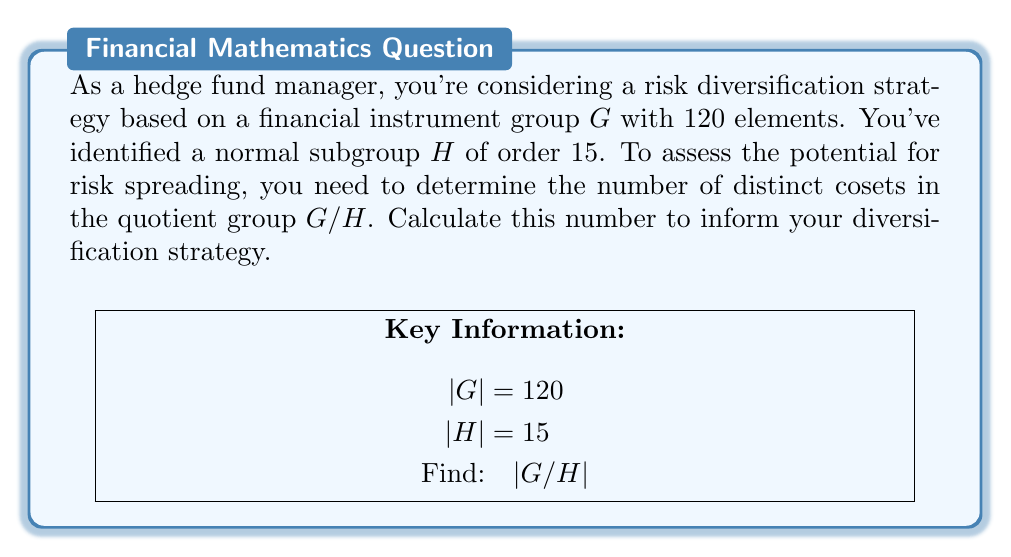Show me your answer to this math problem. Let's approach this step-by-step:

1) First, recall the definition of a quotient group. For a group $G$ and a normal subgroup $H$, the quotient group $G/H$ is the set of all cosets of $H$ in $G$.

2) The number of cosets in $G/H$ is equal to the index of $H$ in $G$, denoted as $[G:H]$.

3) The index $[G:H]$ is given by the formula:

   $$[G:H] = \frac{|G|}{|H|}$$

   where $|G|$ is the order of $G$ and $|H|$ is the order of $H$.

4) We are given that:
   - $|G| = 120$ (the group has 120 elements)
   - $|H| = 15$ (the normal subgroup has order 15)

5) Substituting these values into our formula:

   $$[G:H] = \frac{|G|}{|H|} = \frac{120}{15}$$

6) Simplifying:

   $$[G:H] = 8$$

7) Therefore, there are 8 distinct cosets in the quotient group $G/H$.

In the context of risk diversification, this means you have 8 distinct categories or "buckets" for spreading risk across your financial instruments, based on this particular group structure.
Answer: 8 cosets 